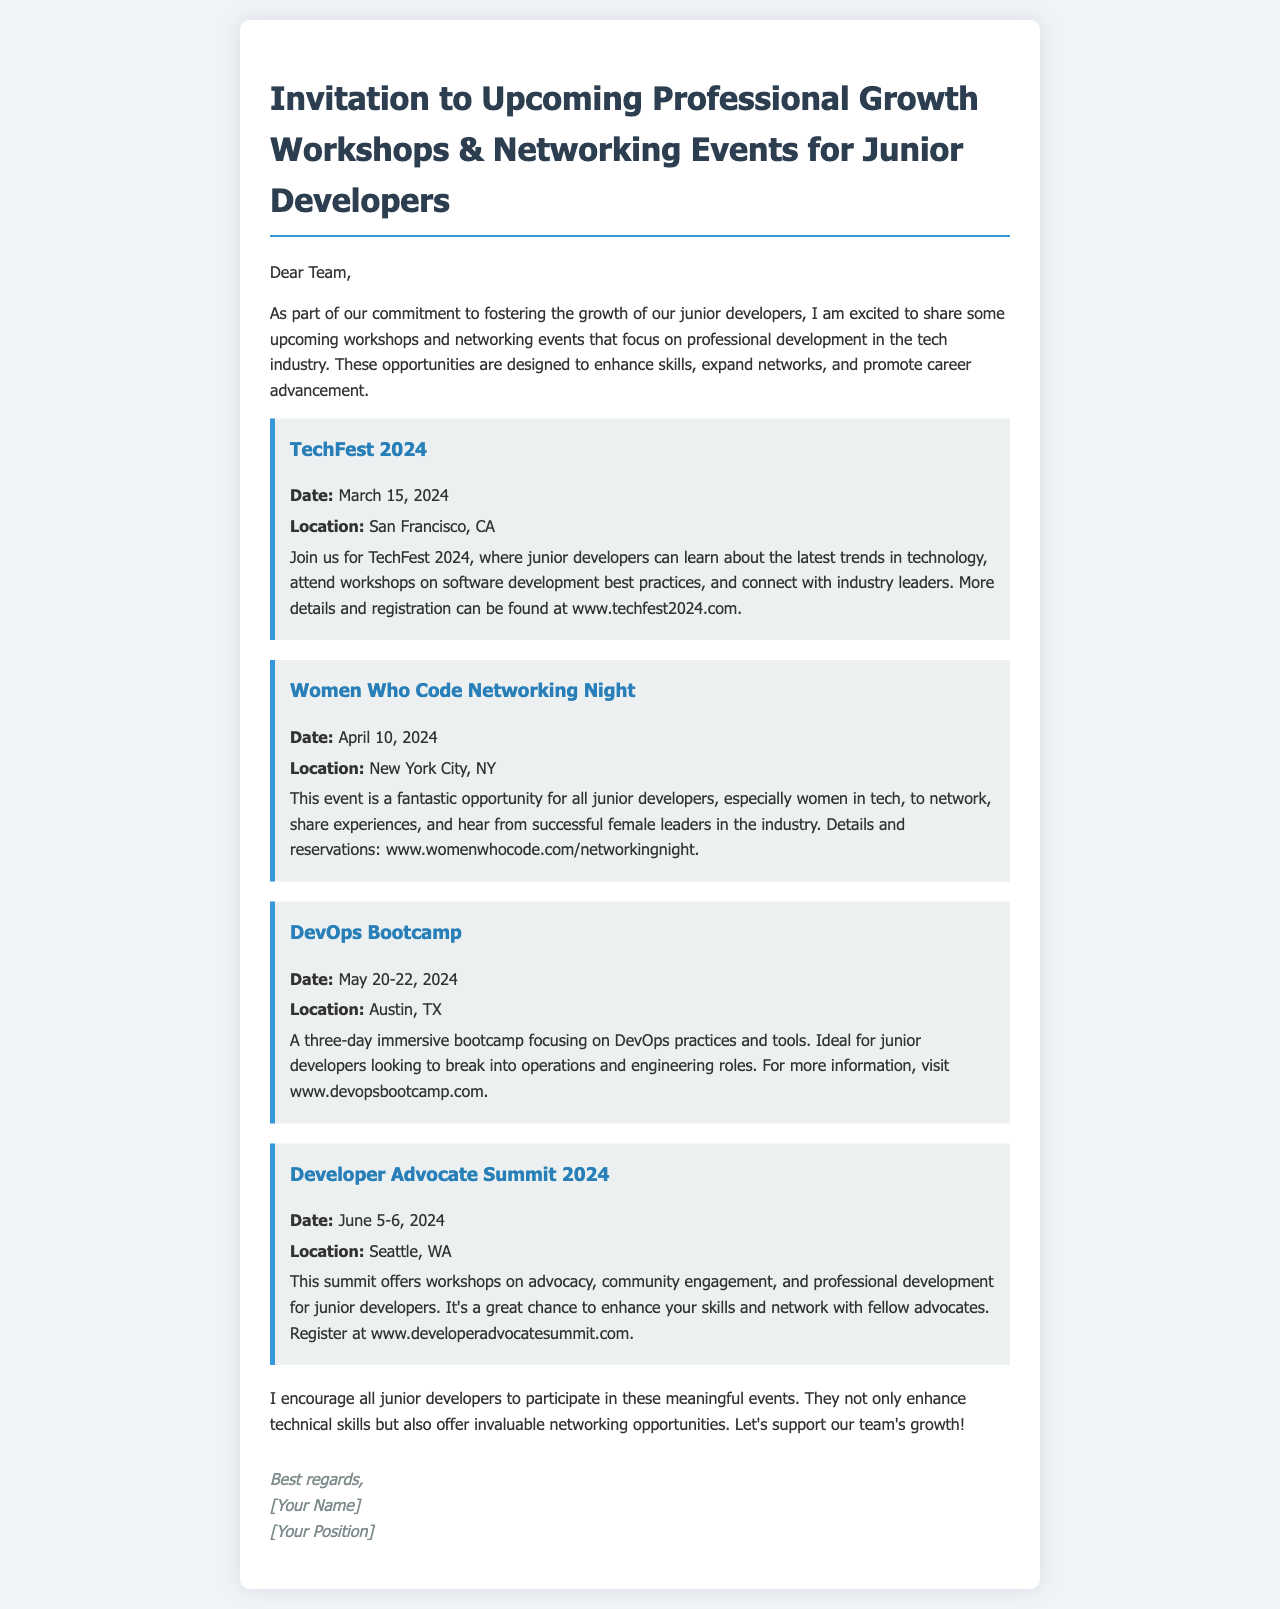what is the date of TechFest 2024? The date for TechFest 2024 is specified in the document as March 15, 2024.
Answer: March 15, 2024 where is the Women Who Code Networking Night taking place? The location mentioned for the Women Who Code Networking Night is New York City, NY.
Answer: New York City, NY how long is the DevOps Bootcamp? The document states that the DevOps Bootcamp lasts for three days, from May 20 to May 22, 2024.
Answer: three days what kind of professionals is the Developer Advocate Summit 2024 designed for? The Developer Advocate Summit 2024 is designed for junior developers, offering workshops on advocacy and community engagement.
Answer: junior developers what is the main focus of the events mentioned in the document? The events are centered on professional growth and networking for junior developers in the tech industry.
Answer: professional growth and networking what is the website for the DevOps Bootcamp? The document provides the link to the DevOps Bootcamp, which is www.devopsbootcamp.com.
Answer: www.devopsbootcamp.com how many events are listed in the document? The number of events mentioned in the document totals four.
Answer: four what opportunities do these events provide for junior developers? The events offer opportunities to enhance skills and expand networks for career advancement.
Answer: enhance skills and expand networks 